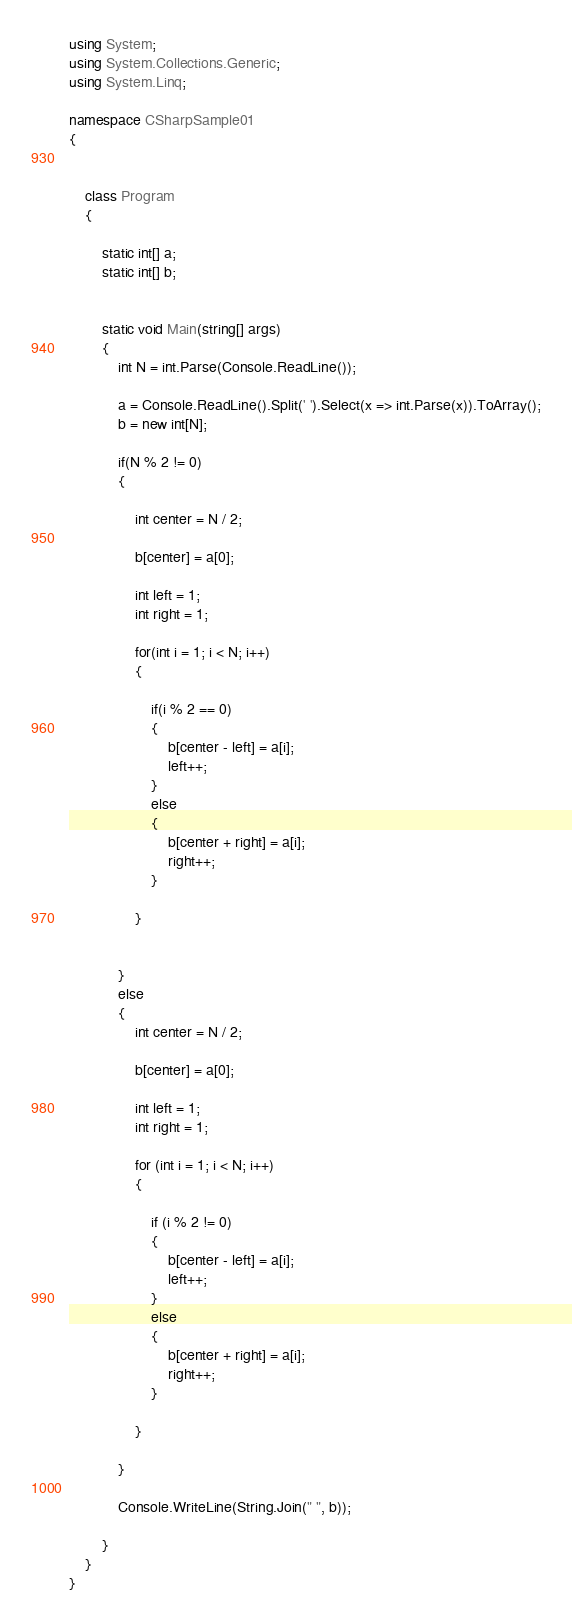<code> <loc_0><loc_0><loc_500><loc_500><_C#_>using System;
using System.Collections.Generic;
using System.Linq;

namespace CSharpSample01
{
    

    class Program
    {

        static int[] a;
        static int[] b;


        static void Main(string[] args)
        {
            int N = int.Parse(Console.ReadLine());

            a = Console.ReadLine().Split(' ').Select(x => int.Parse(x)).ToArray();
            b = new int[N];

            if(N % 2 != 0)
            {

                int center = N / 2;

                b[center] = a[0];

                int left = 1;
                int right = 1;

                for(int i = 1; i < N; i++)
                {

                    if(i % 2 == 0)
                    {
                        b[center - left] = a[i];
                        left++;
                    }
                    else
                    {
                        b[center + right] = a[i];
                        right++;
                    }

                }


            }
            else
            {
                int center = N / 2;

                b[center] = a[0];

                int left = 1;
                int right = 1;

                for (int i = 1; i < N; i++)
                {

                    if (i % 2 != 0)
                    {
                        b[center - left] = a[i];
                        left++;
                    }
                    else
                    {
                        b[center + right] = a[i];
                        right++;
                    }

                }

            }

            Console.WriteLine(String.Join(" ", b));

        }
    }
}
</code> 